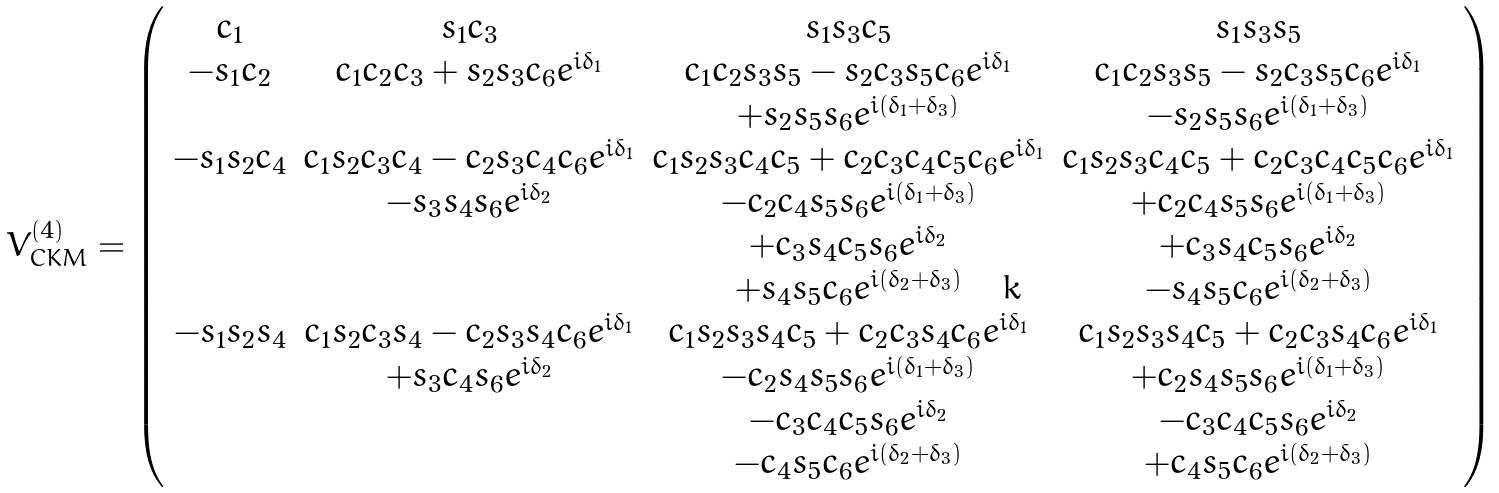Convert formula to latex. <formula><loc_0><loc_0><loc_500><loc_500>V _ { C K M } ^ { ( 4 ) } = \left ( \begin{array} { c c c c } c _ { 1 } & s _ { 1 } c _ { 3 } & s _ { 1 } s _ { 3 } c _ { 5 } & s _ { 1 } s _ { 3 } s _ { 5 } \\ - s _ { 1 } c _ { 2 } & c _ { 1 } c _ { 2 } c _ { 3 } + s _ { 2 } s _ { 3 } c _ { 6 } e ^ { i \delta _ { 1 } } & c _ { 1 } c _ { 2 } s _ { 3 } s _ { 5 } - s _ { 2 } c _ { 3 } s _ { 5 } c _ { 6 } e ^ { i \delta _ { 1 } } & c _ { 1 } c _ { 2 } s _ { 3 } s _ { 5 } - s _ { 2 } c _ { 3 } s _ { 5 } c _ { 6 } e ^ { i \delta _ { 1 } } \\ & & + s _ { 2 } s _ { 5 } s _ { 6 } e ^ { i ( \delta _ { 1 } + \delta _ { 3 } ) } & - s _ { 2 } s _ { 5 } s _ { 6 } e ^ { i ( \delta _ { 1 } + \delta _ { 3 } ) } \\ - s _ { 1 } s _ { 2 } c _ { 4 } & c _ { 1 } s _ { 2 } c _ { 3 } c _ { 4 } - c _ { 2 } s _ { 3 } c _ { 4 } c _ { 6 } e ^ { i \delta _ { 1 } } & c _ { 1 } s _ { 2 } s _ { 3 } c _ { 4 } c _ { 5 } + c _ { 2 } c _ { 3 } c _ { 4 } c _ { 5 } c _ { 6 } e ^ { i \delta _ { 1 } } & c _ { 1 } s _ { 2 } s _ { 3 } c _ { 4 } c _ { 5 } + c _ { 2 } c _ { 3 } c _ { 4 } c _ { 5 } c _ { 6 } e ^ { i \delta _ { 1 } } \\ & - s _ { 3 } s _ { 4 } s _ { 6 } e ^ { i \delta _ { 2 } } & - c _ { 2 } c _ { 4 } s _ { 5 } s _ { 6 } e ^ { i ( \delta _ { 1 } + \delta _ { 3 } ) } & + c _ { 2 } c _ { 4 } s _ { 5 } s _ { 6 } e ^ { i ( \delta _ { 1 } + \delta _ { 3 } ) } \\ & & + c _ { 3 } s _ { 4 } c _ { 5 } s _ { 6 } e ^ { i \delta _ { 2 } } & + c _ { 3 } s _ { 4 } c _ { 5 } s _ { 6 } e ^ { i \delta _ { 2 } } \\ & & + s _ { 4 } s _ { 5 } c _ { 6 } e ^ { i ( \delta _ { 2 } + \delta _ { 3 } ) } & - s _ { 4 } s _ { 5 } c _ { 6 } e ^ { i ( \delta _ { 2 } + \delta _ { 3 } ) } \\ - s _ { 1 } s _ { 2 } s _ { 4 } & c _ { 1 } s _ { 2 } c _ { 3 } s _ { 4 } - c _ { 2 } s _ { 3 } s _ { 4 } c _ { 6 } e ^ { i \delta _ { 1 } } & c _ { 1 } s _ { 2 } s _ { 3 } s _ { 4 } c _ { 5 } + c _ { 2 } c _ { 3 } s _ { 4 } c _ { 6 } e ^ { i \delta _ { 1 } } & c _ { 1 } s _ { 2 } s _ { 3 } s _ { 4 } c _ { 5 } + c _ { 2 } c _ { 3 } s _ { 4 } c _ { 6 } e ^ { i \delta _ { 1 } } \\ & + s _ { 3 } c _ { 4 } s _ { 6 } e ^ { i \delta _ { 2 } } & - c _ { 2 } s _ { 4 } s _ { 5 } s _ { 6 } e ^ { i ( \delta _ { 1 } + \delta _ { 3 } ) } & + c _ { 2 } s _ { 4 } s _ { 5 } s _ { 6 } e ^ { i ( \delta _ { 1 } + \delta _ { 3 } ) } \\ & & - c _ { 3 } c _ { 4 } c _ { 5 } s _ { 6 } e ^ { i \delta _ { 2 } } & - c _ { 3 } c _ { 4 } c _ { 5 } s _ { 6 } e ^ { i \delta _ { 2 } } \\ & & - c _ { 4 } s _ { 5 } c _ { 6 } e ^ { i ( \delta _ { 2 } + \delta _ { 3 } ) } & + c _ { 4 } s _ { 5 } c _ { 6 } e ^ { i ( \delta _ { 2 } + \delta _ { 3 } ) } \end{array} \right )</formula> 